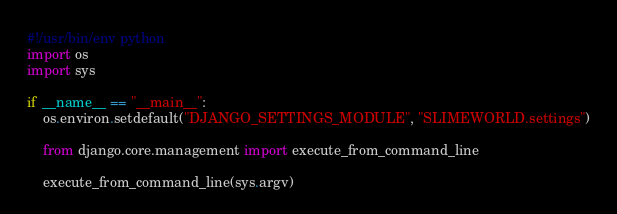<code> <loc_0><loc_0><loc_500><loc_500><_Python_>#!/usr/bin/env python
import os
import sys

if __name__ == "__main__":
    os.environ.setdefault("DJANGO_SETTINGS_MODULE", "SLIMEWORLD.settings")

    from django.core.management import execute_from_command_line

    execute_from_command_line(sys.argv)
</code> 